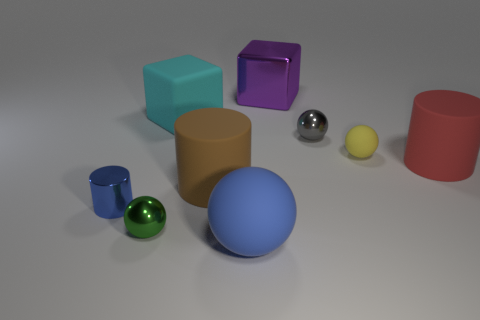Add 1 small yellow rubber objects. How many objects exist? 10 Subtract all cylinders. How many objects are left? 6 Add 5 small gray things. How many small gray things are left? 6 Add 1 tiny blue cylinders. How many tiny blue cylinders exist? 2 Subtract 0 blue cubes. How many objects are left? 9 Subtract all large cyan cubes. Subtract all green objects. How many objects are left? 7 